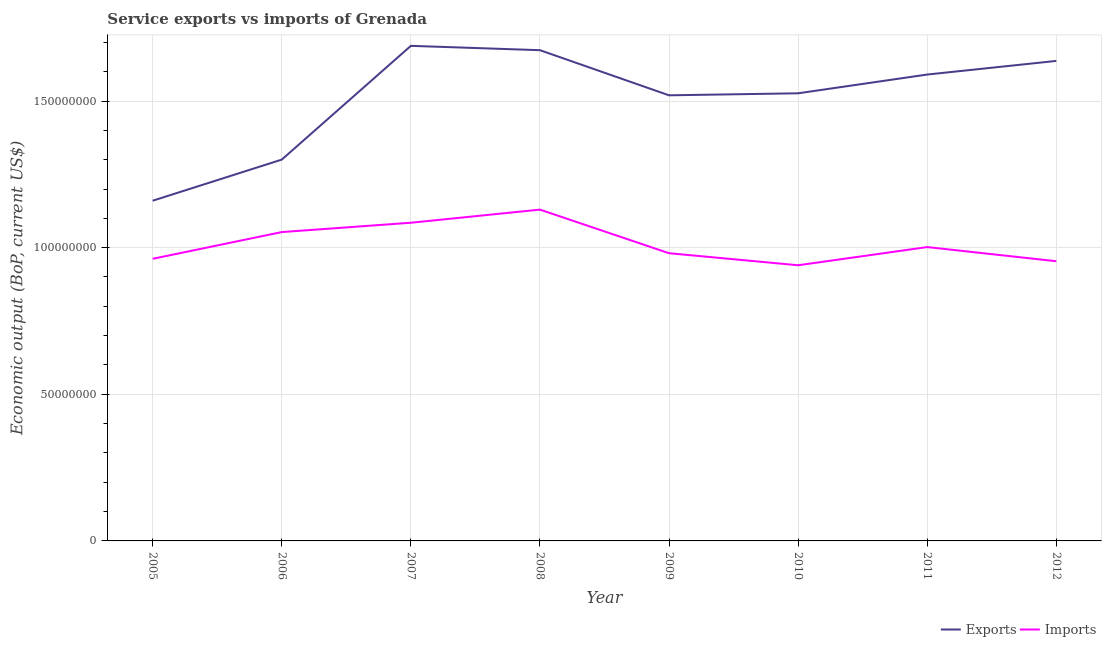How many different coloured lines are there?
Offer a very short reply. 2. Does the line corresponding to amount of service exports intersect with the line corresponding to amount of service imports?
Your answer should be compact. No. What is the amount of service exports in 2007?
Make the answer very short. 1.69e+08. Across all years, what is the maximum amount of service exports?
Provide a succinct answer. 1.69e+08. Across all years, what is the minimum amount of service imports?
Make the answer very short. 9.40e+07. In which year was the amount of service imports maximum?
Offer a terse response. 2008. In which year was the amount of service imports minimum?
Your response must be concise. 2010. What is the total amount of service imports in the graph?
Your answer should be very brief. 8.11e+08. What is the difference between the amount of service exports in 2005 and that in 2007?
Offer a very short reply. -5.28e+07. What is the difference between the amount of service imports in 2012 and the amount of service exports in 2009?
Offer a terse response. -5.66e+07. What is the average amount of service imports per year?
Your answer should be compact. 1.01e+08. In the year 2009, what is the difference between the amount of service imports and amount of service exports?
Provide a short and direct response. -5.38e+07. In how many years, is the amount of service exports greater than 110000000 US$?
Provide a short and direct response. 8. What is the ratio of the amount of service imports in 2005 to that in 2012?
Make the answer very short. 1.01. Is the amount of service exports in 2006 less than that in 2012?
Your response must be concise. Yes. What is the difference between the highest and the second highest amount of service exports?
Your answer should be compact. 1.48e+06. What is the difference between the highest and the lowest amount of service exports?
Ensure brevity in your answer.  5.28e+07. Is the amount of service imports strictly greater than the amount of service exports over the years?
Ensure brevity in your answer.  No. Is the amount of service imports strictly less than the amount of service exports over the years?
Make the answer very short. Yes. How many lines are there?
Give a very brief answer. 2. Are the values on the major ticks of Y-axis written in scientific E-notation?
Provide a short and direct response. No. Does the graph contain any zero values?
Your answer should be very brief. No. What is the title of the graph?
Keep it short and to the point. Service exports vs imports of Grenada. What is the label or title of the Y-axis?
Keep it short and to the point. Economic output (BoP, current US$). What is the Economic output (BoP, current US$) of Exports in 2005?
Provide a short and direct response. 1.16e+08. What is the Economic output (BoP, current US$) in Imports in 2005?
Offer a terse response. 9.62e+07. What is the Economic output (BoP, current US$) of Exports in 2006?
Keep it short and to the point. 1.30e+08. What is the Economic output (BoP, current US$) in Imports in 2006?
Your response must be concise. 1.05e+08. What is the Economic output (BoP, current US$) of Exports in 2007?
Your answer should be compact. 1.69e+08. What is the Economic output (BoP, current US$) in Imports in 2007?
Your answer should be very brief. 1.08e+08. What is the Economic output (BoP, current US$) of Exports in 2008?
Your answer should be compact. 1.67e+08. What is the Economic output (BoP, current US$) in Imports in 2008?
Make the answer very short. 1.13e+08. What is the Economic output (BoP, current US$) in Exports in 2009?
Provide a short and direct response. 1.52e+08. What is the Economic output (BoP, current US$) in Imports in 2009?
Your answer should be compact. 9.81e+07. What is the Economic output (BoP, current US$) in Exports in 2010?
Provide a short and direct response. 1.53e+08. What is the Economic output (BoP, current US$) in Imports in 2010?
Make the answer very short. 9.40e+07. What is the Economic output (BoP, current US$) in Exports in 2011?
Your answer should be very brief. 1.59e+08. What is the Economic output (BoP, current US$) in Imports in 2011?
Your answer should be very brief. 1.00e+08. What is the Economic output (BoP, current US$) in Exports in 2012?
Keep it short and to the point. 1.64e+08. What is the Economic output (BoP, current US$) in Imports in 2012?
Your answer should be compact. 9.54e+07. Across all years, what is the maximum Economic output (BoP, current US$) of Exports?
Offer a very short reply. 1.69e+08. Across all years, what is the maximum Economic output (BoP, current US$) of Imports?
Provide a succinct answer. 1.13e+08. Across all years, what is the minimum Economic output (BoP, current US$) of Exports?
Your response must be concise. 1.16e+08. Across all years, what is the minimum Economic output (BoP, current US$) in Imports?
Your answer should be very brief. 9.40e+07. What is the total Economic output (BoP, current US$) in Exports in the graph?
Offer a terse response. 1.21e+09. What is the total Economic output (BoP, current US$) of Imports in the graph?
Ensure brevity in your answer.  8.11e+08. What is the difference between the Economic output (BoP, current US$) of Exports in 2005 and that in 2006?
Your response must be concise. -1.40e+07. What is the difference between the Economic output (BoP, current US$) of Imports in 2005 and that in 2006?
Your answer should be compact. -9.11e+06. What is the difference between the Economic output (BoP, current US$) of Exports in 2005 and that in 2007?
Provide a short and direct response. -5.28e+07. What is the difference between the Economic output (BoP, current US$) of Imports in 2005 and that in 2007?
Your answer should be compact. -1.23e+07. What is the difference between the Economic output (BoP, current US$) in Exports in 2005 and that in 2008?
Your answer should be compact. -5.13e+07. What is the difference between the Economic output (BoP, current US$) in Imports in 2005 and that in 2008?
Offer a very short reply. -1.68e+07. What is the difference between the Economic output (BoP, current US$) in Exports in 2005 and that in 2009?
Offer a terse response. -3.59e+07. What is the difference between the Economic output (BoP, current US$) in Imports in 2005 and that in 2009?
Give a very brief answer. -1.91e+06. What is the difference between the Economic output (BoP, current US$) in Exports in 2005 and that in 2010?
Offer a very short reply. -3.66e+07. What is the difference between the Economic output (BoP, current US$) in Imports in 2005 and that in 2010?
Provide a succinct answer. 2.20e+06. What is the difference between the Economic output (BoP, current US$) of Exports in 2005 and that in 2011?
Keep it short and to the point. -4.30e+07. What is the difference between the Economic output (BoP, current US$) in Imports in 2005 and that in 2011?
Your answer should be compact. -4.00e+06. What is the difference between the Economic output (BoP, current US$) of Exports in 2005 and that in 2012?
Your response must be concise. -4.77e+07. What is the difference between the Economic output (BoP, current US$) in Imports in 2005 and that in 2012?
Your answer should be very brief. 8.28e+05. What is the difference between the Economic output (BoP, current US$) of Exports in 2006 and that in 2007?
Offer a very short reply. -3.88e+07. What is the difference between the Economic output (BoP, current US$) in Imports in 2006 and that in 2007?
Provide a succinct answer. -3.19e+06. What is the difference between the Economic output (BoP, current US$) of Exports in 2006 and that in 2008?
Offer a very short reply. -3.73e+07. What is the difference between the Economic output (BoP, current US$) of Imports in 2006 and that in 2008?
Offer a very short reply. -7.66e+06. What is the difference between the Economic output (BoP, current US$) in Exports in 2006 and that in 2009?
Make the answer very short. -2.19e+07. What is the difference between the Economic output (BoP, current US$) of Imports in 2006 and that in 2009?
Offer a terse response. 7.21e+06. What is the difference between the Economic output (BoP, current US$) of Exports in 2006 and that in 2010?
Ensure brevity in your answer.  -2.26e+07. What is the difference between the Economic output (BoP, current US$) in Imports in 2006 and that in 2010?
Provide a short and direct response. 1.13e+07. What is the difference between the Economic output (BoP, current US$) in Exports in 2006 and that in 2011?
Give a very brief answer. -2.90e+07. What is the difference between the Economic output (BoP, current US$) of Imports in 2006 and that in 2011?
Your answer should be very brief. 5.11e+06. What is the difference between the Economic output (BoP, current US$) in Exports in 2006 and that in 2012?
Your response must be concise. -3.37e+07. What is the difference between the Economic output (BoP, current US$) of Imports in 2006 and that in 2012?
Make the answer very short. 9.94e+06. What is the difference between the Economic output (BoP, current US$) in Exports in 2007 and that in 2008?
Your response must be concise. 1.48e+06. What is the difference between the Economic output (BoP, current US$) in Imports in 2007 and that in 2008?
Give a very brief answer. -4.47e+06. What is the difference between the Economic output (BoP, current US$) in Exports in 2007 and that in 2009?
Give a very brief answer. 1.69e+07. What is the difference between the Economic output (BoP, current US$) in Imports in 2007 and that in 2009?
Offer a terse response. 1.04e+07. What is the difference between the Economic output (BoP, current US$) of Exports in 2007 and that in 2010?
Give a very brief answer. 1.62e+07. What is the difference between the Economic output (BoP, current US$) in Imports in 2007 and that in 2010?
Provide a succinct answer. 1.45e+07. What is the difference between the Economic output (BoP, current US$) in Exports in 2007 and that in 2011?
Provide a short and direct response. 9.79e+06. What is the difference between the Economic output (BoP, current US$) of Imports in 2007 and that in 2011?
Your answer should be very brief. 8.30e+06. What is the difference between the Economic output (BoP, current US$) of Exports in 2007 and that in 2012?
Your answer should be compact. 5.14e+06. What is the difference between the Economic output (BoP, current US$) in Imports in 2007 and that in 2012?
Offer a terse response. 1.31e+07. What is the difference between the Economic output (BoP, current US$) of Exports in 2008 and that in 2009?
Your answer should be very brief. 1.54e+07. What is the difference between the Economic output (BoP, current US$) of Imports in 2008 and that in 2009?
Your answer should be compact. 1.49e+07. What is the difference between the Economic output (BoP, current US$) of Exports in 2008 and that in 2010?
Make the answer very short. 1.47e+07. What is the difference between the Economic output (BoP, current US$) in Imports in 2008 and that in 2010?
Provide a succinct answer. 1.90e+07. What is the difference between the Economic output (BoP, current US$) of Exports in 2008 and that in 2011?
Offer a terse response. 8.31e+06. What is the difference between the Economic output (BoP, current US$) in Imports in 2008 and that in 2011?
Offer a very short reply. 1.28e+07. What is the difference between the Economic output (BoP, current US$) of Exports in 2008 and that in 2012?
Your answer should be compact. 3.66e+06. What is the difference between the Economic output (BoP, current US$) of Imports in 2008 and that in 2012?
Offer a terse response. 1.76e+07. What is the difference between the Economic output (BoP, current US$) in Exports in 2009 and that in 2010?
Your answer should be compact. -6.91e+05. What is the difference between the Economic output (BoP, current US$) of Imports in 2009 and that in 2010?
Make the answer very short. 4.11e+06. What is the difference between the Economic output (BoP, current US$) of Exports in 2009 and that in 2011?
Keep it short and to the point. -7.08e+06. What is the difference between the Economic output (BoP, current US$) in Imports in 2009 and that in 2011?
Offer a terse response. -2.10e+06. What is the difference between the Economic output (BoP, current US$) in Exports in 2009 and that in 2012?
Make the answer very short. -1.17e+07. What is the difference between the Economic output (BoP, current US$) of Imports in 2009 and that in 2012?
Your response must be concise. 2.73e+06. What is the difference between the Economic output (BoP, current US$) of Exports in 2010 and that in 2011?
Keep it short and to the point. -6.39e+06. What is the difference between the Economic output (BoP, current US$) of Imports in 2010 and that in 2011?
Give a very brief answer. -6.20e+06. What is the difference between the Economic output (BoP, current US$) of Exports in 2010 and that in 2012?
Provide a succinct answer. -1.10e+07. What is the difference between the Economic output (BoP, current US$) in Imports in 2010 and that in 2012?
Your answer should be compact. -1.37e+06. What is the difference between the Economic output (BoP, current US$) in Exports in 2011 and that in 2012?
Offer a terse response. -4.65e+06. What is the difference between the Economic output (BoP, current US$) of Imports in 2011 and that in 2012?
Offer a terse response. 4.83e+06. What is the difference between the Economic output (BoP, current US$) in Exports in 2005 and the Economic output (BoP, current US$) in Imports in 2006?
Provide a succinct answer. 1.07e+07. What is the difference between the Economic output (BoP, current US$) in Exports in 2005 and the Economic output (BoP, current US$) in Imports in 2007?
Provide a short and direct response. 7.51e+06. What is the difference between the Economic output (BoP, current US$) of Exports in 2005 and the Economic output (BoP, current US$) of Imports in 2008?
Provide a short and direct response. 3.04e+06. What is the difference between the Economic output (BoP, current US$) in Exports in 2005 and the Economic output (BoP, current US$) in Imports in 2009?
Provide a succinct answer. 1.79e+07. What is the difference between the Economic output (BoP, current US$) in Exports in 2005 and the Economic output (BoP, current US$) in Imports in 2010?
Ensure brevity in your answer.  2.20e+07. What is the difference between the Economic output (BoP, current US$) in Exports in 2005 and the Economic output (BoP, current US$) in Imports in 2011?
Make the answer very short. 1.58e+07. What is the difference between the Economic output (BoP, current US$) of Exports in 2005 and the Economic output (BoP, current US$) of Imports in 2012?
Give a very brief answer. 2.06e+07. What is the difference between the Economic output (BoP, current US$) of Exports in 2006 and the Economic output (BoP, current US$) of Imports in 2007?
Make the answer very short. 2.15e+07. What is the difference between the Economic output (BoP, current US$) of Exports in 2006 and the Economic output (BoP, current US$) of Imports in 2008?
Your response must be concise. 1.71e+07. What is the difference between the Economic output (BoP, current US$) in Exports in 2006 and the Economic output (BoP, current US$) in Imports in 2009?
Your response must be concise. 3.19e+07. What is the difference between the Economic output (BoP, current US$) of Exports in 2006 and the Economic output (BoP, current US$) of Imports in 2010?
Your answer should be very brief. 3.60e+07. What is the difference between the Economic output (BoP, current US$) in Exports in 2006 and the Economic output (BoP, current US$) in Imports in 2011?
Your answer should be very brief. 2.98e+07. What is the difference between the Economic output (BoP, current US$) of Exports in 2006 and the Economic output (BoP, current US$) of Imports in 2012?
Provide a short and direct response. 3.47e+07. What is the difference between the Economic output (BoP, current US$) of Exports in 2007 and the Economic output (BoP, current US$) of Imports in 2008?
Offer a terse response. 5.58e+07. What is the difference between the Economic output (BoP, current US$) of Exports in 2007 and the Economic output (BoP, current US$) of Imports in 2009?
Provide a short and direct response. 7.07e+07. What is the difference between the Economic output (BoP, current US$) of Exports in 2007 and the Economic output (BoP, current US$) of Imports in 2010?
Provide a short and direct response. 7.48e+07. What is the difference between the Economic output (BoP, current US$) in Exports in 2007 and the Economic output (BoP, current US$) in Imports in 2011?
Give a very brief answer. 6.86e+07. What is the difference between the Economic output (BoP, current US$) in Exports in 2007 and the Economic output (BoP, current US$) in Imports in 2012?
Your answer should be compact. 7.34e+07. What is the difference between the Economic output (BoP, current US$) in Exports in 2008 and the Economic output (BoP, current US$) in Imports in 2009?
Offer a terse response. 6.92e+07. What is the difference between the Economic output (BoP, current US$) of Exports in 2008 and the Economic output (BoP, current US$) of Imports in 2010?
Offer a terse response. 7.33e+07. What is the difference between the Economic output (BoP, current US$) in Exports in 2008 and the Economic output (BoP, current US$) in Imports in 2011?
Give a very brief answer. 6.71e+07. What is the difference between the Economic output (BoP, current US$) in Exports in 2008 and the Economic output (BoP, current US$) in Imports in 2012?
Give a very brief answer. 7.20e+07. What is the difference between the Economic output (BoP, current US$) of Exports in 2009 and the Economic output (BoP, current US$) of Imports in 2010?
Provide a short and direct response. 5.79e+07. What is the difference between the Economic output (BoP, current US$) in Exports in 2009 and the Economic output (BoP, current US$) in Imports in 2011?
Offer a very short reply. 5.17e+07. What is the difference between the Economic output (BoP, current US$) of Exports in 2009 and the Economic output (BoP, current US$) of Imports in 2012?
Offer a very short reply. 5.66e+07. What is the difference between the Economic output (BoP, current US$) of Exports in 2010 and the Economic output (BoP, current US$) of Imports in 2011?
Provide a short and direct response. 5.24e+07. What is the difference between the Economic output (BoP, current US$) of Exports in 2010 and the Economic output (BoP, current US$) of Imports in 2012?
Keep it short and to the point. 5.73e+07. What is the difference between the Economic output (BoP, current US$) of Exports in 2011 and the Economic output (BoP, current US$) of Imports in 2012?
Offer a very short reply. 6.37e+07. What is the average Economic output (BoP, current US$) of Exports per year?
Your answer should be very brief. 1.51e+08. What is the average Economic output (BoP, current US$) in Imports per year?
Give a very brief answer. 1.01e+08. In the year 2005, what is the difference between the Economic output (BoP, current US$) in Exports and Economic output (BoP, current US$) in Imports?
Provide a succinct answer. 1.98e+07. In the year 2006, what is the difference between the Economic output (BoP, current US$) of Exports and Economic output (BoP, current US$) of Imports?
Your response must be concise. 2.47e+07. In the year 2007, what is the difference between the Economic output (BoP, current US$) of Exports and Economic output (BoP, current US$) of Imports?
Your response must be concise. 6.03e+07. In the year 2008, what is the difference between the Economic output (BoP, current US$) in Exports and Economic output (BoP, current US$) in Imports?
Offer a very short reply. 5.44e+07. In the year 2009, what is the difference between the Economic output (BoP, current US$) in Exports and Economic output (BoP, current US$) in Imports?
Ensure brevity in your answer.  5.38e+07. In the year 2010, what is the difference between the Economic output (BoP, current US$) in Exports and Economic output (BoP, current US$) in Imports?
Your answer should be compact. 5.86e+07. In the year 2011, what is the difference between the Economic output (BoP, current US$) in Exports and Economic output (BoP, current US$) in Imports?
Give a very brief answer. 5.88e+07. In the year 2012, what is the difference between the Economic output (BoP, current US$) in Exports and Economic output (BoP, current US$) in Imports?
Your answer should be very brief. 6.83e+07. What is the ratio of the Economic output (BoP, current US$) in Exports in 2005 to that in 2006?
Offer a terse response. 0.89. What is the ratio of the Economic output (BoP, current US$) in Imports in 2005 to that in 2006?
Offer a very short reply. 0.91. What is the ratio of the Economic output (BoP, current US$) in Exports in 2005 to that in 2007?
Make the answer very short. 0.69. What is the ratio of the Economic output (BoP, current US$) in Imports in 2005 to that in 2007?
Your answer should be very brief. 0.89. What is the ratio of the Economic output (BoP, current US$) of Exports in 2005 to that in 2008?
Make the answer very short. 0.69. What is the ratio of the Economic output (BoP, current US$) of Imports in 2005 to that in 2008?
Give a very brief answer. 0.85. What is the ratio of the Economic output (BoP, current US$) of Exports in 2005 to that in 2009?
Provide a short and direct response. 0.76. What is the ratio of the Economic output (BoP, current US$) in Imports in 2005 to that in 2009?
Your answer should be compact. 0.98. What is the ratio of the Economic output (BoP, current US$) in Exports in 2005 to that in 2010?
Ensure brevity in your answer.  0.76. What is the ratio of the Economic output (BoP, current US$) in Imports in 2005 to that in 2010?
Give a very brief answer. 1.02. What is the ratio of the Economic output (BoP, current US$) of Exports in 2005 to that in 2011?
Offer a very short reply. 0.73. What is the ratio of the Economic output (BoP, current US$) in Imports in 2005 to that in 2011?
Ensure brevity in your answer.  0.96. What is the ratio of the Economic output (BoP, current US$) of Exports in 2005 to that in 2012?
Your response must be concise. 0.71. What is the ratio of the Economic output (BoP, current US$) in Imports in 2005 to that in 2012?
Give a very brief answer. 1.01. What is the ratio of the Economic output (BoP, current US$) in Exports in 2006 to that in 2007?
Ensure brevity in your answer.  0.77. What is the ratio of the Economic output (BoP, current US$) in Imports in 2006 to that in 2007?
Offer a very short reply. 0.97. What is the ratio of the Economic output (BoP, current US$) of Exports in 2006 to that in 2008?
Your response must be concise. 0.78. What is the ratio of the Economic output (BoP, current US$) in Imports in 2006 to that in 2008?
Your response must be concise. 0.93. What is the ratio of the Economic output (BoP, current US$) in Exports in 2006 to that in 2009?
Offer a terse response. 0.86. What is the ratio of the Economic output (BoP, current US$) in Imports in 2006 to that in 2009?
Ensure brevity in your answer.  1.07. What is the ratio of the Economic output (BoP, current US$) of Exports in 2006 to that in 2010?
Ensure brevity in your answer.  0.85. What is the ratio of the Economic output (BoP, current US$) of Imports in 2006 to that in 2010?
Ensure brevity in your answer.  1.12. What is the ratio of the Economic output (BoP, current US$) in Exports in 2006 to that in 2011?
Make the answer very short. 0.82. What is the ratio of the Economic output (BoP, current US$) of Imports in 2006 to that in 2011?
Offer a terse response. 1.05. What is the ratio of the Economic output (BoP, current US$) of Exports in 2006 to that in 2012?
Offer a terse response. 0.79. What is the ratio of the Economic output (BoP, current US$) of Imports in 2006 to that in 2012?
Your answer should be very brief. 1.1. What is the ratio of the Economic output (BoP, current US$) of Exports in 2007 to that in 2008?
Your response must be concise. 1.01. What is the ratio of the Economic output (BoP, current US$) of Imports in 2007 to that in 2008?
Ensure brevity in your answer.  0.96. What is the ratio of the Economic output (BoP, current US$) in Exports in 2007 to that in 2009?
Provide a short and direct response. 1.11. What is the ratio of the Economic output (BoP, current US$) of Imports in 2007 to that in 2009?
Your answer should be compact. 1.11. What is the ratio of the Economic output (BoP, current US$) in Exports in 2007 to that in 2010?
Keep it short and to the point. 1.11. What is the ratio of the Economic output (BoP, current US$) in Imports in 2007 to that in 2010?
Ensure brevity in your answer.  1.15. What is the ratio of the Economic output (BoP, current US$) in Exports in 2007 to that in 2011?
Your response must be concise. 1.06. What is the ratio of the Economic output (BoP, current US$) of Imports in 2007 to that in 2011?
Offer a very short reply. 1.08. What is the ratio of the Economic output (BoP, current US$) in Exports in 2007 to that in 2012?
Make the answer very short. 1.03. What is the ratio of the Economic output (BoP, current US$) of Imports in 2007 to that in 2012?
Your response must be concise. 1.14. What is the ratio of the Economic output (BoP, current US$) of Exports in 2008 to that in 2009?
Your response must be concise. 1.1. What is the ratio of the Economic output (BoP, current US$) of Imports in 2008 to that in 2009?
Ensure brevity in your answer.  1.15. What is the ratio of the Economic output (BoP, current US$) of Exports in 2008 to that in 2010?
Your answer should be compact. 1.1. What is the ratio of the Economic output (BoP, current US$) of Imports in 2008 to that in 2010?
Provide a succinct answer. 1.2. What is the ratio of the Economic output (BoP, current US$) of Exports in 2008 to that in 2011?
Provide a succinct answer. 1.05. What is the ratio of the Economic output (BoP, current US$) in Imports in 2008 to that in 2011?
Provide a succinct answer. 1.13. What is the ratio of the Economic output (BoP, current US$) in Exports in 2008 to that in 2012?
Ensure brevity in your answer.  1.02. What is the ratio of the Economic output (BoP, current US$) in Imports in 2008 to that in 2012?
Your response must be concise. 1.18. What is the ratio of the Economic output (BoP, current US$) in Exports in 2009 to that in 2010?
Provide a short and direct response. 1. What is the ratio of the Economic output (BoP, current US$) in Imports in 2009 to that in 2010?
Your answer should be compact. 1.04. What is the ratio of the Economic output (BoP, current US$) of Exports in 2009 to that in 2011?
Make the answer very short. 0.96. What is the ratio of the Economic output (BoP, current US$) in Imports in 2009 to that in 2011?
Offer a very short reply. 0.98. What is the ratio of the Economic output (BoP, current US$) of Exports in 2009 to that in 2012?
Offer a terse response. 0.93. What is the ratio of the Economic output (BoP, current US$) of Imports in 2009 to that in 2012?
Offer a very short reply. 1.03. What is the ratio of the Economic output (BoP, current US$) of Exports in 2010 to that in 2011?
Ensure brevity in your answer.  0.96. What is the ratio of the Economic output (BoP, current US$) of Imports in 2010 to that in 2011?
Offer a very short reply. 0.94. What is the ratio of the Economic output (BoP, current US$) in Exports in 2010 to that in 2012?
Keep it short and to the point. 0.93. What is the ratio of the Economic output (BoP, current US$) of Imports in 2010 to that in 2012?
Offer a terse response. 0.99. What is the ratio of the Economic output (BoP, current US$) in Exports in 2011 to that in 2012?
Your answer should be very brief. 0.97. What is the ratio of the Economic output (BoP, current US$) in Imports in 2011 to that in 2012?
Your answer should be compact. 1.05. What is the difference between the highest and the second highest Economic output (BoP, current US$) of Exports?
Make the answer very short. 1.48e+06. What is the difference between the highest and the second highest Economic output (BoP, current US$) of Imports?
Your answer should be compact. 4.47e+06. What is the difference between the highest and the lowest Economic output (BoP, current US$) of Exports?
Your response must be concise. 5.28e+07. What is the difference between the highest and the lowest Economic output (BoP, current US$) of Imports?
Your response must be concise. 1.90e+07. 